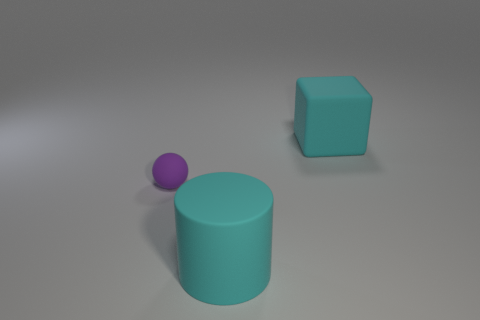Add 2 rubber blocks. How many objects exist? 5 Subtract all cubes. How many objects are left? 2 Subtract 0 yellow cylinders. How many objects are left? 3 Subtract all large brown blocks. Subtract all tiny purple objects. How many objects are left? 2 Add 3 purple matte objects. How many purple matte objects are left? 4 Add 3 tiny matte cubes. How many tiny matte cubes exist? 3 